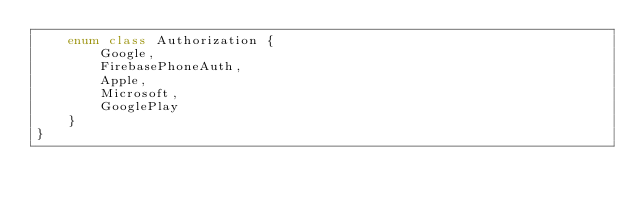<code> <loc_0><loc_0><loc_500><loc_500><_Kotlin_>    enum class Authorization {
        Google,
        FirebasePhoneAuth,
        Apple,
        Microsoft,
        GooglePlay
    }
}
</code> 